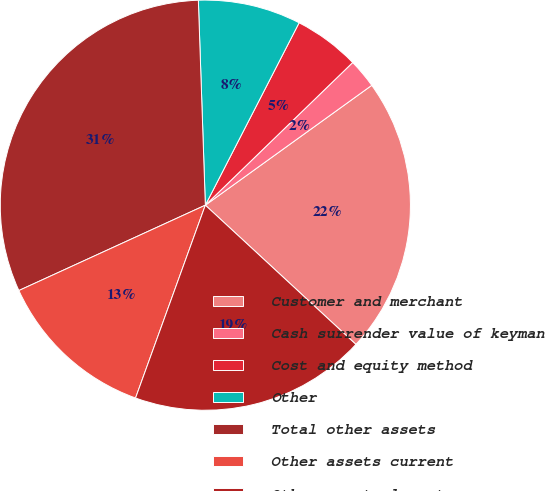Convert chart. <chart><loc_0><loc_0><loc_500><loc_500><pie_chart><fcel>Customer and merchant<fcel>Cash surrender value of keyman<fcel>Cost and equity method<fcel>Other<fcel>Total other assets<fcel>Other assets current<fcel>Other assets long-term<nl><fcel>21.81%<fcel>2.31%<fcel>5.2%<fcel>8.1%<fcel>31.29%<fcel>12.64%<fcel>18.65%<nl></chart> 